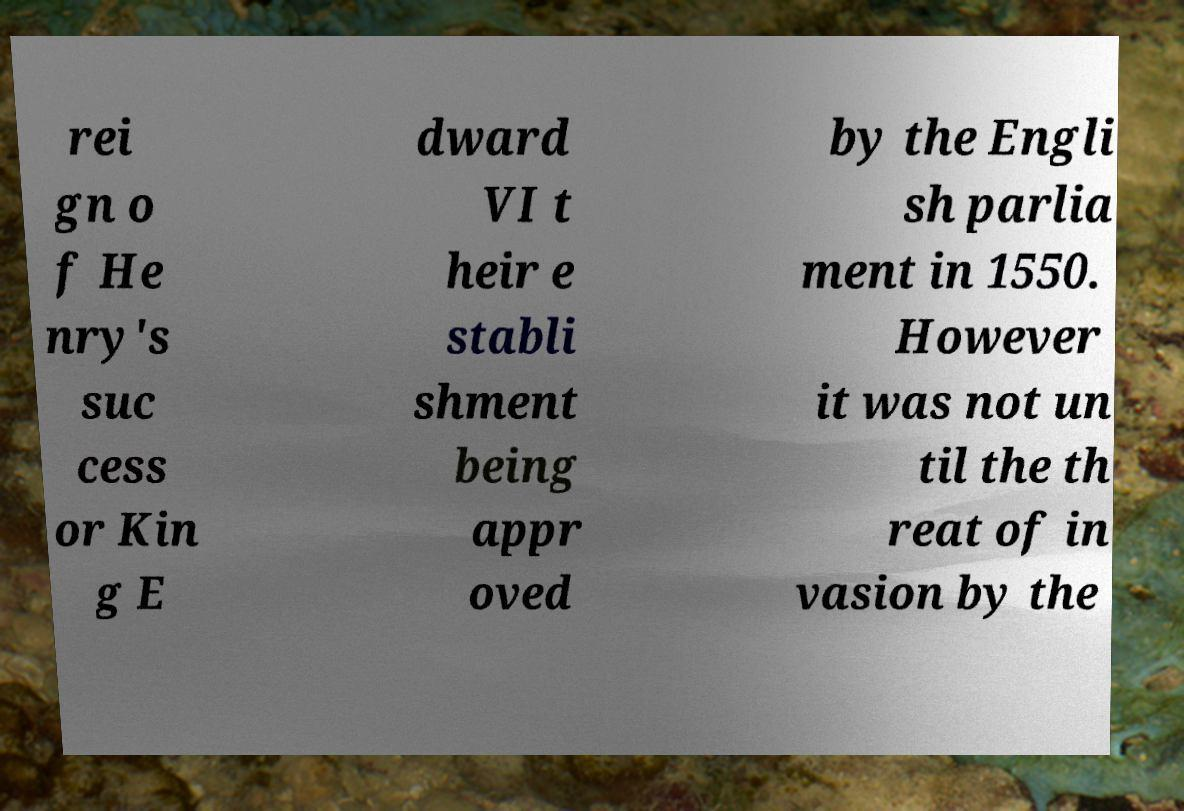For documentation purposes, I need the text within this image transcribed. Could you provide that? rei gn o f He nry's suc cess or Kin g E dward VI t heir e stabli shment being appr oved by the Engli sh parlia ment in 1550. However it was not un til the th reat of in vasion by the 